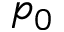<formula> <loc_0><loc_0><loc_500><loc_500>p _ { 0 }</formula> 